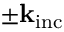Convert formula to latex. <formula><loc_0><loc_0><loc_500><loc_500>\pm k _ { i n c }</formula> 